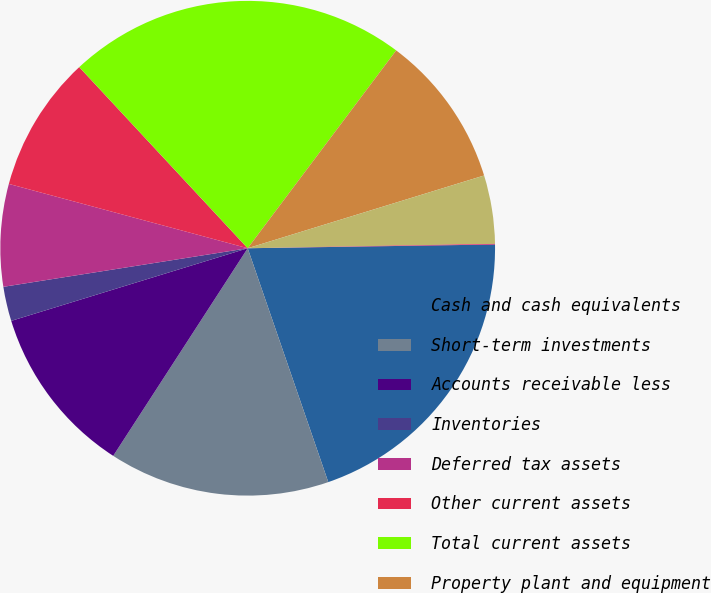Convert chart to OTSL. <chart><loc_0><loc_0><loc_500><loc_500><pie_chart><fcel>Cash and cash equivalents<fcel>Short-term investments<fcel>Accounts receivable less<fcel>Inventories<fcel>Deferred tax assets<fcel>Other current assets<fcel>Total current assets<fcel>Property plant and equipment<fcel>Goodwill<fcel>Acquired intangible assets<nl><fcel>19.96%<fcel>14.43%<fcel>11.11%<fcel>2.25%<fcel>6.68%<fcel>8.89%<fcel>22.17%<fcel>10.0%<fcel>4.47%<fcel>0.04%<nl></chart> 